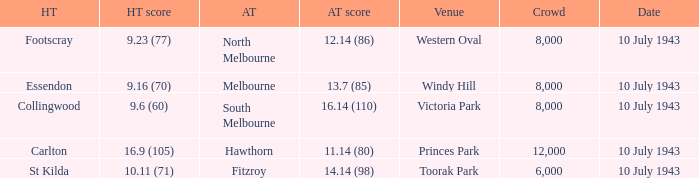When the Away team scored 14.14 (98), which Venue did the game take place? Toorak Park. 